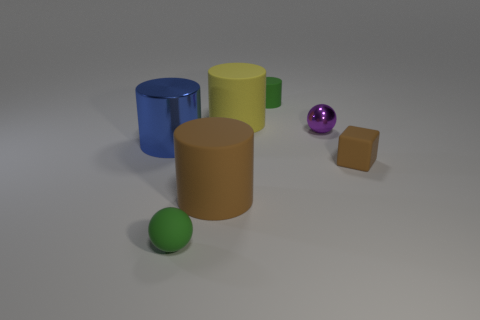Can you tell me which objects in the image are closest to the purple shiny sphere? The yellow matte cylinder and the brown rubber block are the objects nearest to the purple shiny sphere, creating a visually interesting cluster of shapes and colors in the composition. What does the arrangement of these objects suggest about the lighting of the scene? The shadows and highlights on the objects indicate a single, diffused light source from above, casting subtle shadows and soft lighting that contributes to the overall serene atsmosphere of the scene. 